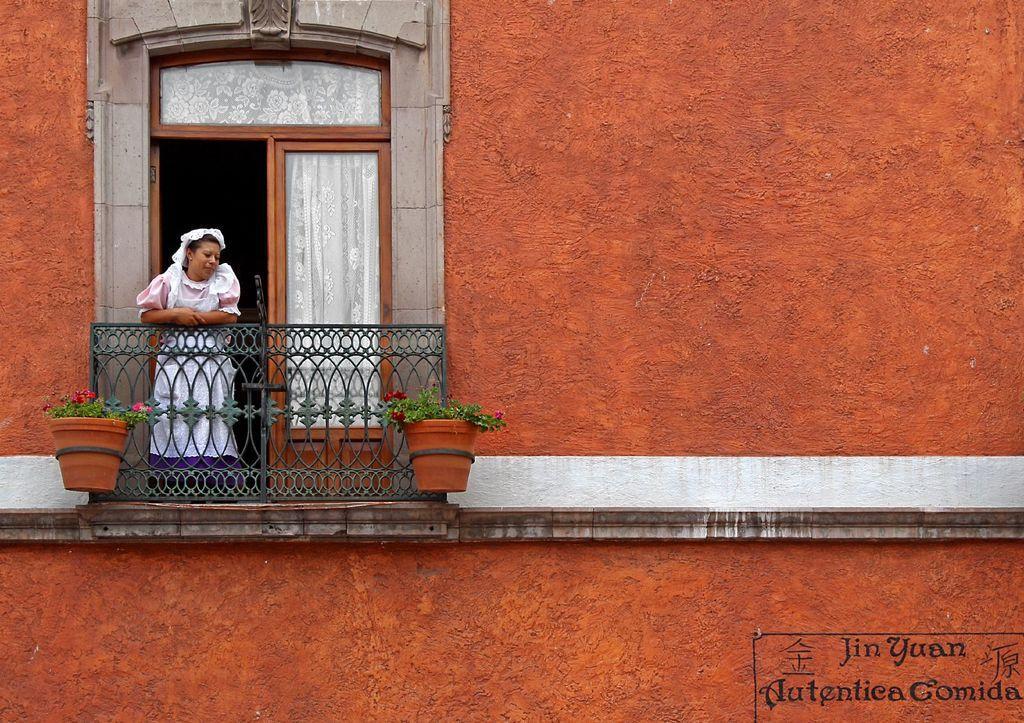Please provide a concise description of this image. In this image there is a building and there is a railing behind the railing there is a woman standing and in front of the railing there are flowers in the pots and there is a door. 